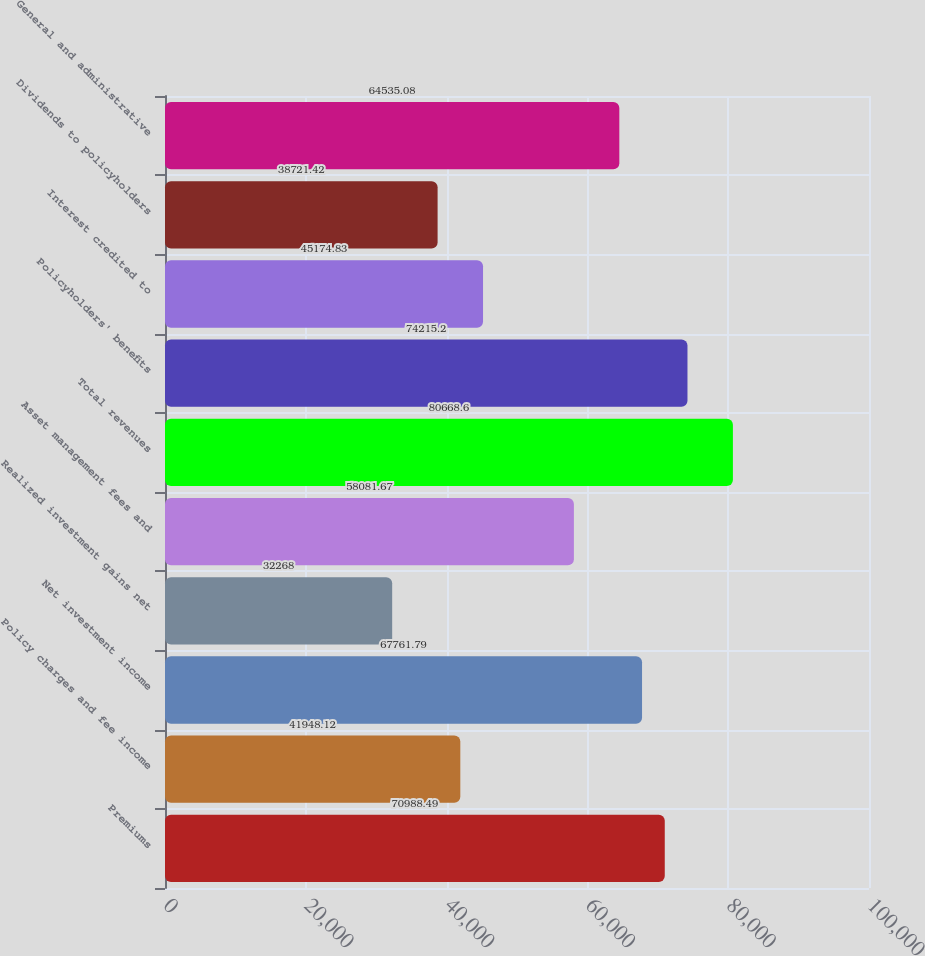Convert chart. <chart><loc_0><loc_0><loc_500><loc_500><bar_chart><fcel>Premiums<fcel>Policy charges and fee income<fcel>Net investment income<fcel>Realized investment gains net<fcel>Asset management fees and<fcel>Total revenues<fcel>Policyholders' benefits<fcel>Interest credited to<fcel>Dividends to policyholders<fcel>General and administrative<nl><fcel>70988.5<fcel>41948.1<fcel>67761.8<fcel>32268<fcel>58081.7<fcel>80668.6<fcel>74215.2<fcel>45174.8<fcel>38721.4<fcel>64535.1<nl></chart> 